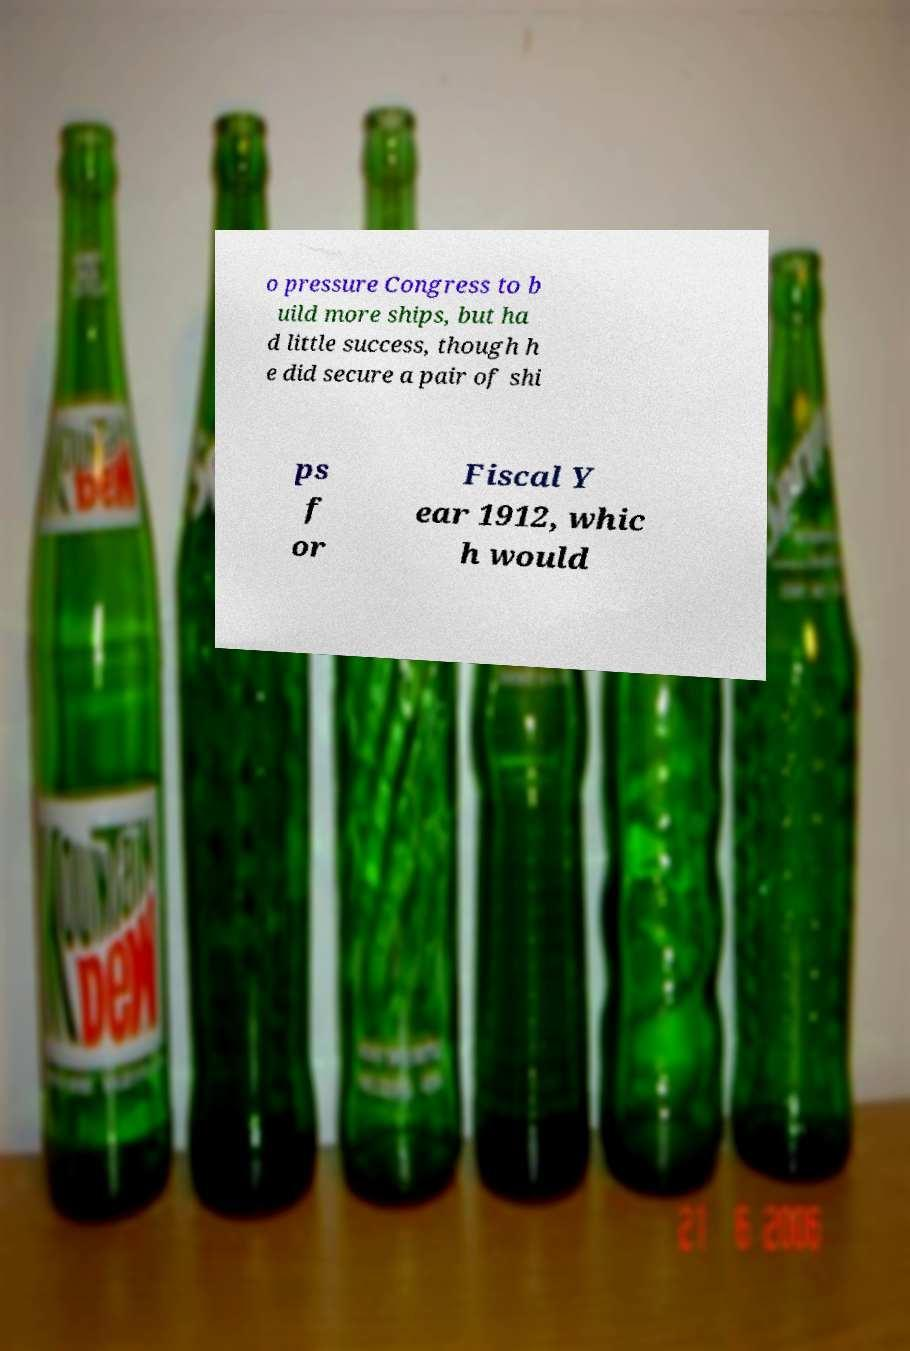Can you accurately transcribe the text from the provided image for me? o pressure Congress to b uild more ships, but ha d little success, though h e did secure a pair of shi ps f or Fiscal Y ear 1912, whic h would 